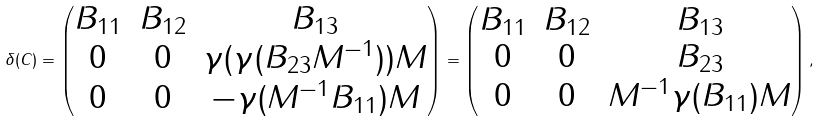<formula> <loc_0><loc_0><loc_500><loc_500>\delta ( C ) = \left ( \begin{matrix} B _ { 1 1 } & B _ { 1 2 } & B _ { 1 3 } \\ 0 & 0 & \gamma ( \gamma ( B _ { 2 3 } M ^ { - 1 } ) ) M \\ 0 & 0 & - \gamma ( M ^ { - 1 } B _ { 1 1 } ) M \end{matrix} \right ) = \left ( \begin{matrix} B _ { 1 1 } & B _ { 1 2 } & B _ { 1 3 } \\ 0 & 0 & B _ { 2 3 } \\ 0 & 0 & M ^ { - 1 } \gamma ( B _ { 1 1 } ) M \end{matrix} \right ) ,</formula> 